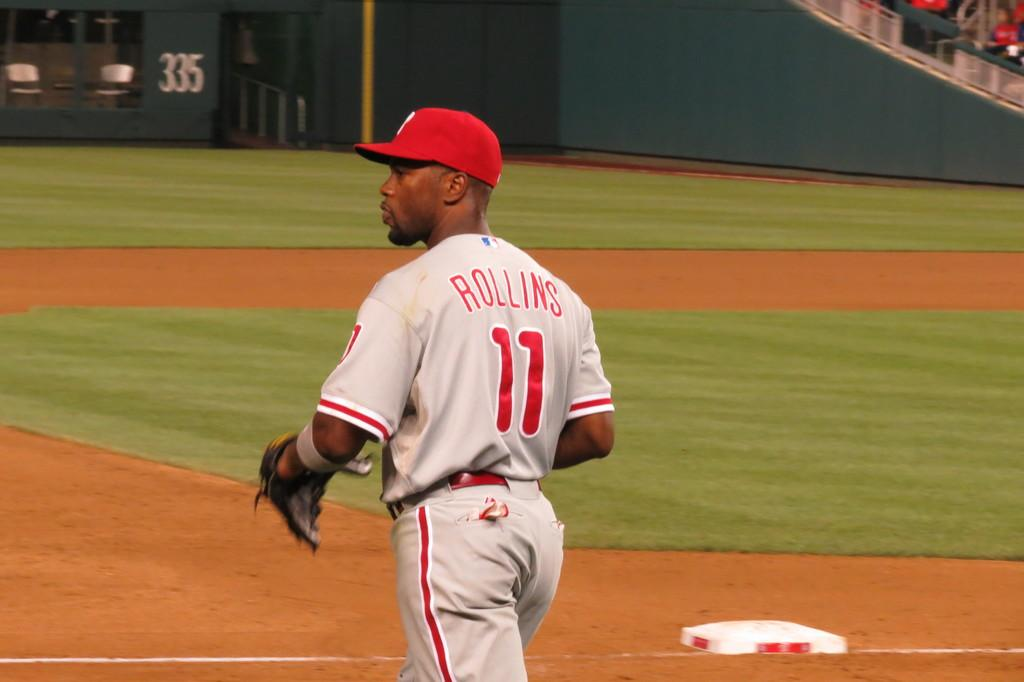<image>
Render a clear and concise summary of the photo. A baseball player stands on the field he is Rollins `` 